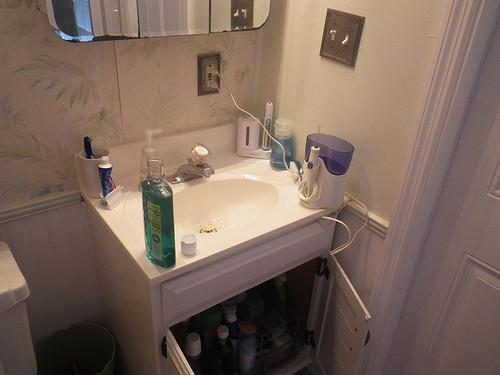What is the status of the light switches in the image? There are two light switches: one is turned up, and the other is turned down. How many different types of toothpaste can you find in the image? There is only one type of toothpaste visible in the image. How many items can you find on the sink counter? There are at least 8 items on the sink counter: cap, mouthwash, toothpaste, faucet, drain, soap dispenser, electric flosser, and hand soap. Examine the image and determine the overall setting or ambiance. The image depicts a moderately cluttered and lived-in bathroom environment. Are there any items near the sink that are related to oral hygiene? Yes, there are several items related to oral hygiene near the sink, including toothpaste, mouthwash, an electric toothbrush, and an electric flosser. What full-size objects can be seen partially in the image? The edge of a toilet and a part of a white wall area can be seen partially in the image. What color is the liquid inside the mouthwash bottle? The liquid inside the mouthwash bottle is greenish-blue. Can you identify any electronic devices in the image? Yes, there are at least two electronic devices: an electric toothbrush and an electric flosser. Describe any visible hygiene or cleaning products in the image. Some visible hygiene and cleaning products include mouthwash, toothpaste, a tube of bathroom cleaner in a cabinet, and a bottle of hand soap. Briefly state what the bathroom consists of. The bathroom consists of a sink, mirror, toilet, waste basket, cabinet, and various toiletry items such as toothpaste and mouthwash. 